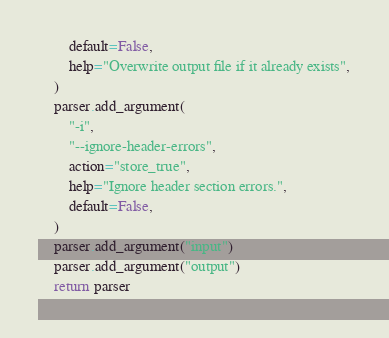Convert code to text. <code><loc_0><loc_0><loc_500><loc_500><_Python_>        default=False,
        help="Overwrite output file if it already exists",
    )
    parser.add_argument(
        "-i",
        "--ignore-header-errors",
        action="store_true",
        help="Ignore header section errors.",
        default=False,
    )
    parser.add_argument("input")
    parser.add_argument("output")
    return parser
</code> 